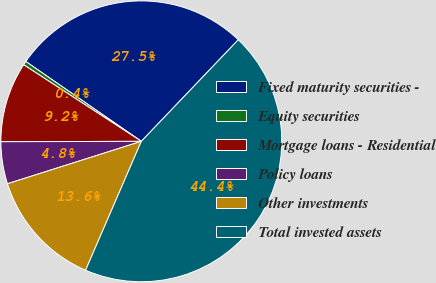Convert chart. <chart><loc_0><loc_0><loc_500><loc_500><pie_chart><fcel>Fixed maturity securities -<fcel>Equity securities<fcel>Mortgage loans - Residential<fcel>Policy loans<fcel>Other investments<fcel>Total invested assets<nl><fcel>27.51%<fcel>0.44%<fcel>9.23%<fcel>4.84%<fcel>13.62%<fcel>44.37%<nl></chart> 